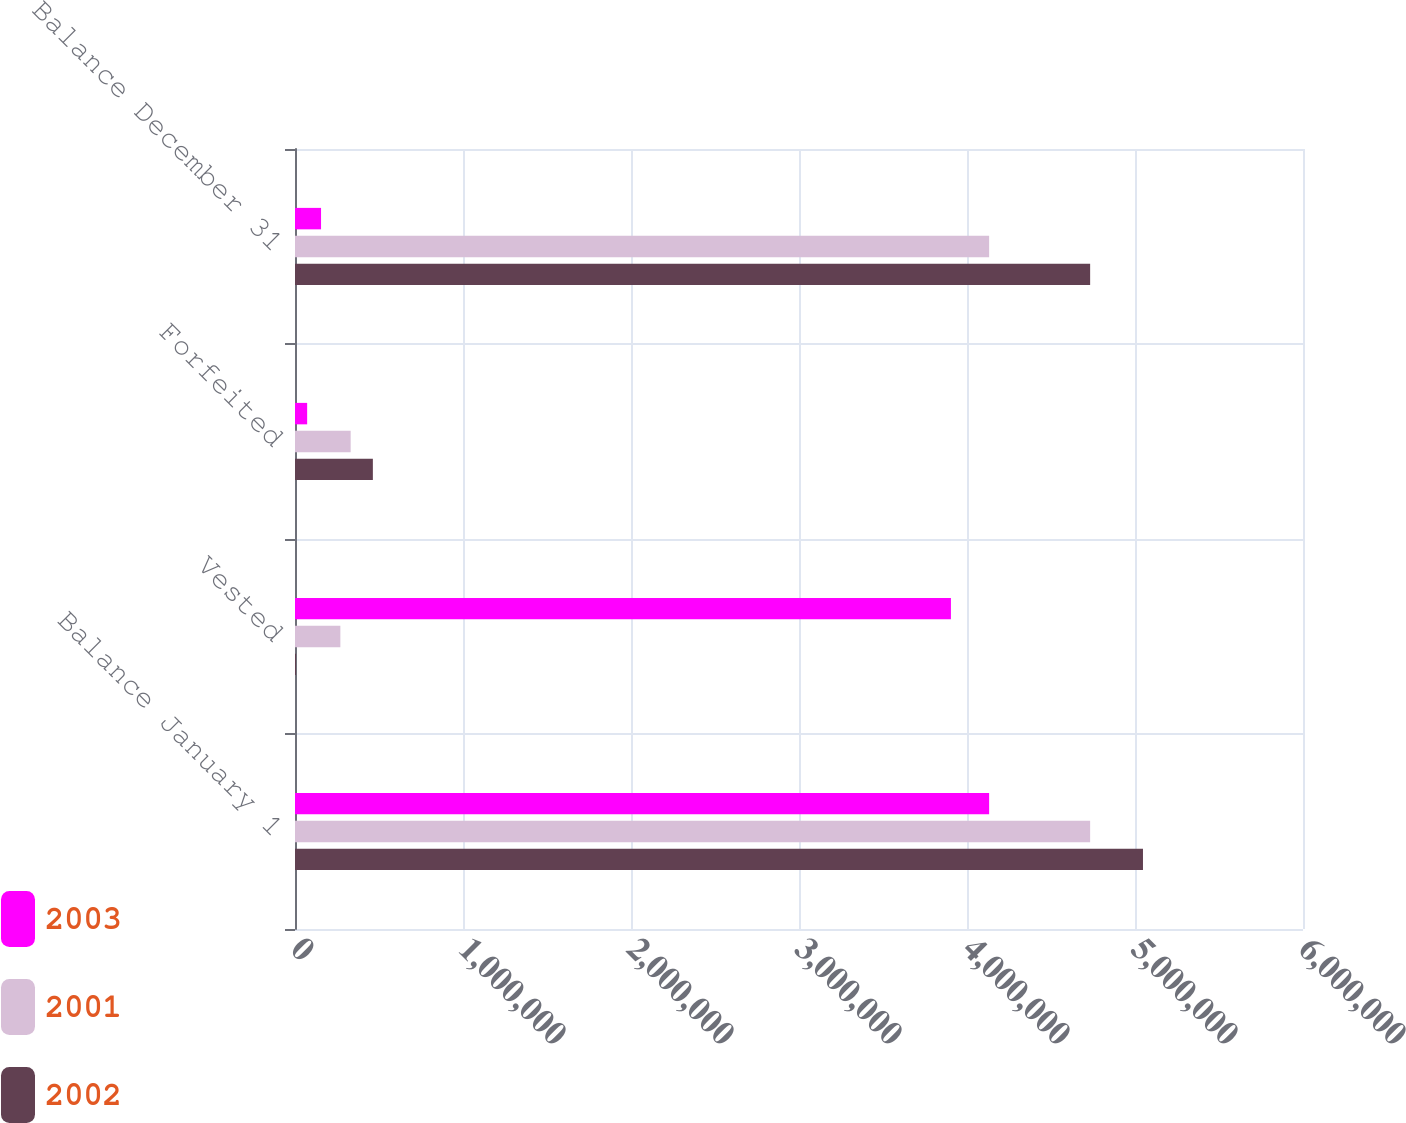<chart> <loc_0><loc_0><loc_500><loc_500><stacked_bar_chart><ecel><fcel>Balance January 1<fcel>Vested<fcel>Forfeited<fcel>Balance December 31<nl><fcel>2003<fcel>4.13173e+06<fcel>3.90438e+06<fcel>72344<fcel>155000<nl><fcel>2001<fcel>4.733e+06<fcel>270000<fcel>331274<fcel>4.13173e+06<nl><fcel>2002<fcel>5.0475e+06<fcel>6000<fcel>463500<fcel>4.733e+06<nl></chart> 